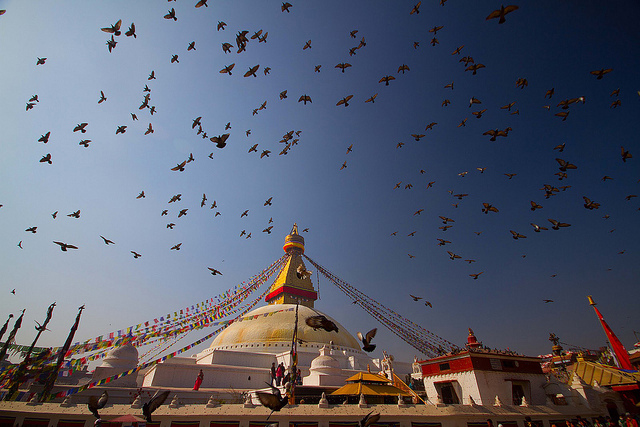<image>What movie does this resemble? I don't know what movie this resembles. It can be the movie "Birds" or an Indian film. What movie does this resemble? I don't know what movie this resembles. It can be similar to 'birds' or 'indian film'. 